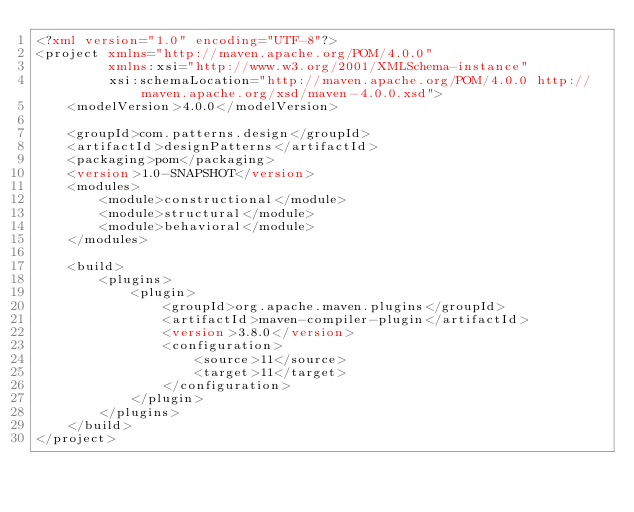<code> <loc_0><loc_0><loc_500><loc_500><_XML_><?xml version="1.0" encoding="UTF-8"?>
<project xmlns="http://maven.apache.org/POM/4.0.0"
         xmlns:xsi="http://www.w3.org/2001/XMLSchema-instance"
         xsi:schemaLocation="http://maven.apache.org/POM/4.0.0 http://maven.apache.org/xsd/maven-4.0.0.xsd">
    <modelVersion>4.0.0</modelVersion>

    <groupId>com.patterns.design</groupId>
    <artifactId>designPatterns</artifactId>
    <packaging>pom</packaging>
    <version>1.0-SNAPSHOT</version>
    <modules>
        <module>constructional</module>
        <module>structural</module>
        <module>behavioral</module>
    </modules>

    <build>
        <plugins>
            <plugin>
                <groupId>org.apache.maven.plugins</groupId>
                <artifactId>maven-compiler-plugin</artifactId>
                <version>3.8.0</version>
                <configuration>
                    <source>11</source>
                    <target>11</target>
                </configuration>
            </plugin>
        </plugins>
    </build>
</project></code> 